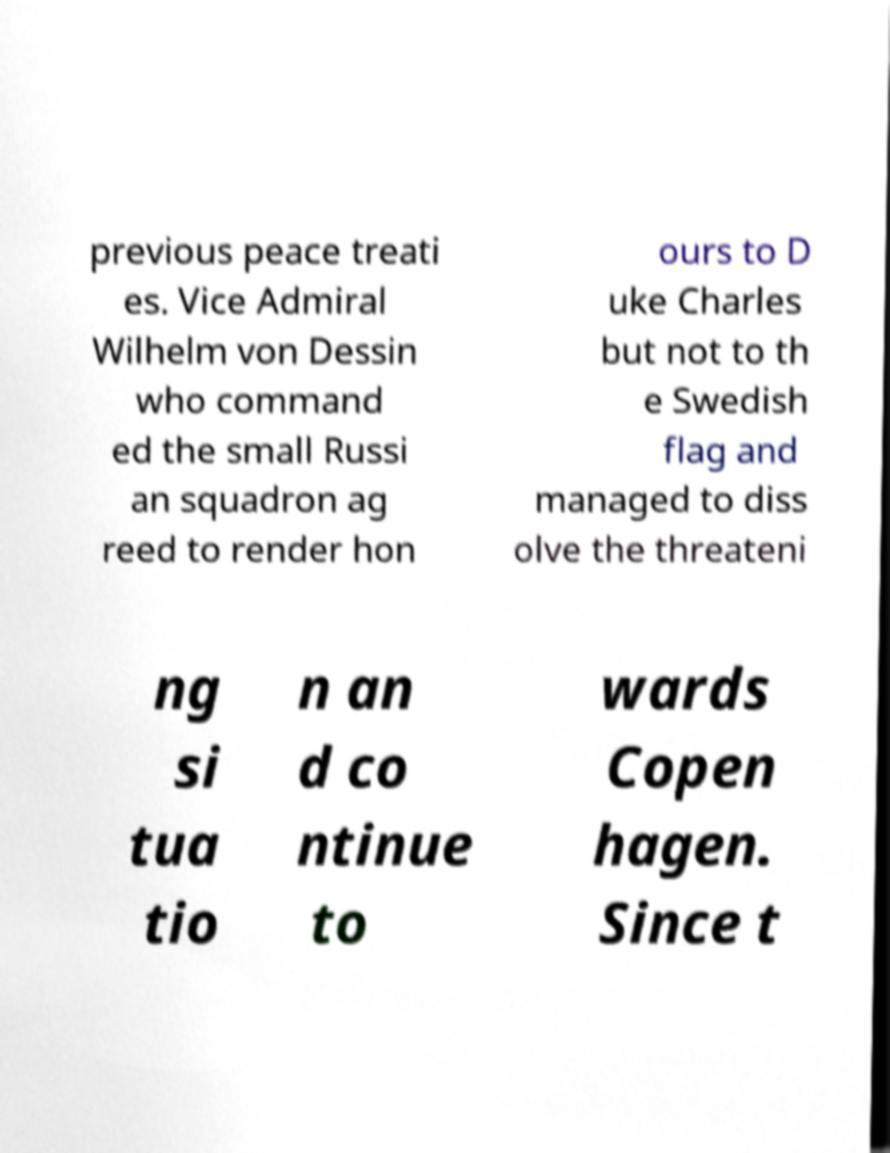Please identify and transcribe the text found in this image. previous peace treati es. Vice Admiral Wilhelm von Dessin who command ed the small Russi an squadron ag reed to render hon ours to D uke Charles but not to th e Swedish flag and managed to diss olve the threateni ng si tua tio n an d co ntinue to wards Copen hagen. Since t 